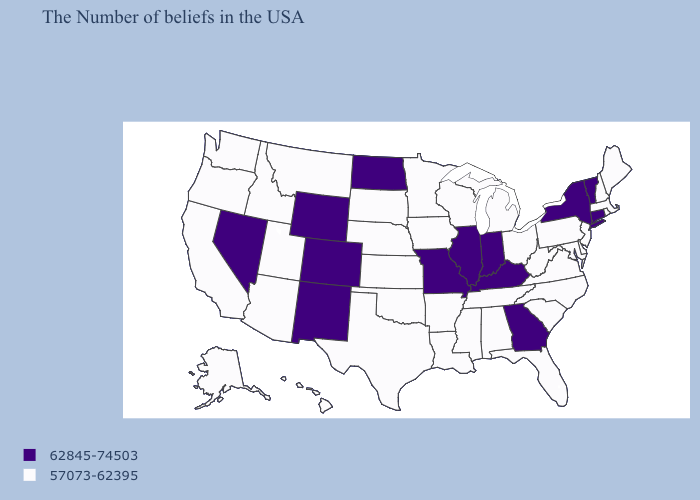What is the value of Alabama?
Answer briefly. 57073-62395. Does Kansas have the same value as Connecticut?
Answer briefly. No. Which states have the highest value in the USA?
Quick response, please. Vermont, Connecticut, New York, Georgia, Kentucky, Indiana, Illinois, Missouri, North Dakota, Wyoming, Colorado, New Mexico, Nevada. Which states have the highest value in the USA?
Quick response, please. Vermont, Connecticut, New York, Georgia, Kentucky, Indiana, Illinois, Missouri, North Dakota, Wyoming, Colorado, New Mexico, Nevada. Name the states that have a value in the range 62845-74503?
Keep it brief. Vermont, Connecticut, New York, Georgia, Kentucky, Indiana, Illinois, Missouri, North Dakota, Wyoming, Colorado, New Mexico, Nevada. What is the highest value in states that border South Dakota?
Short answer required. 62845-74503. Name the states that have a value in the range 62845-74503?
Keep it brief. Vermont, Connecticut, New York, Georgia, Kentucky, Indiana, Illinois, Missouri, North Dakota, Wyoming, Colorado, New Mexico, Nevada. Among the states that border Indiana , which have the highest value?
Be succinct. Kentucky, Illinois. What is the lowest value in the USA?
Concise answer only. 57073-62395. Does the first symbol in the legend represent the smallest category?
Short answer required. No. What is the lowest value in states that border North Dakota?
Be succinct. 57073-62395. Among the states that border Illinois , which have the highest value?
Give a very brief answer. Kentucky, Indiana, Missouri. What is the highest value in the South ?
Quick response, please. 62845-74503. What is the value of Idaho?
Concise answer only. 57073-62395. 